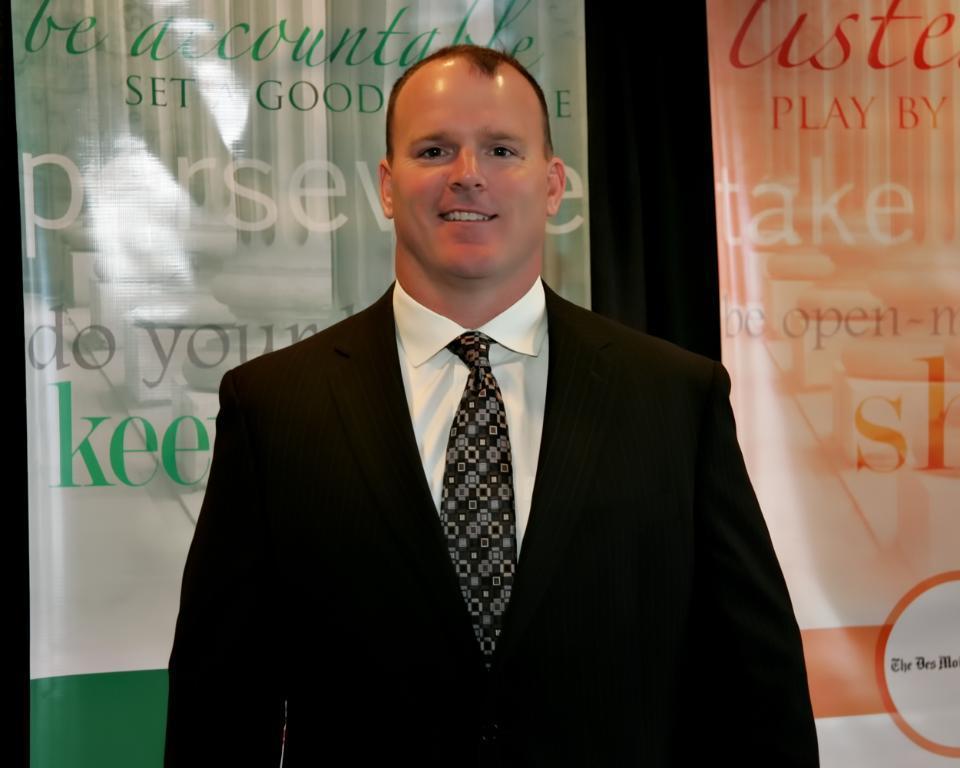Could you give a brief overview of what you see in this image? In this image we can see there is a person standing with a smile on his face, behind him there is a banner with some text. 